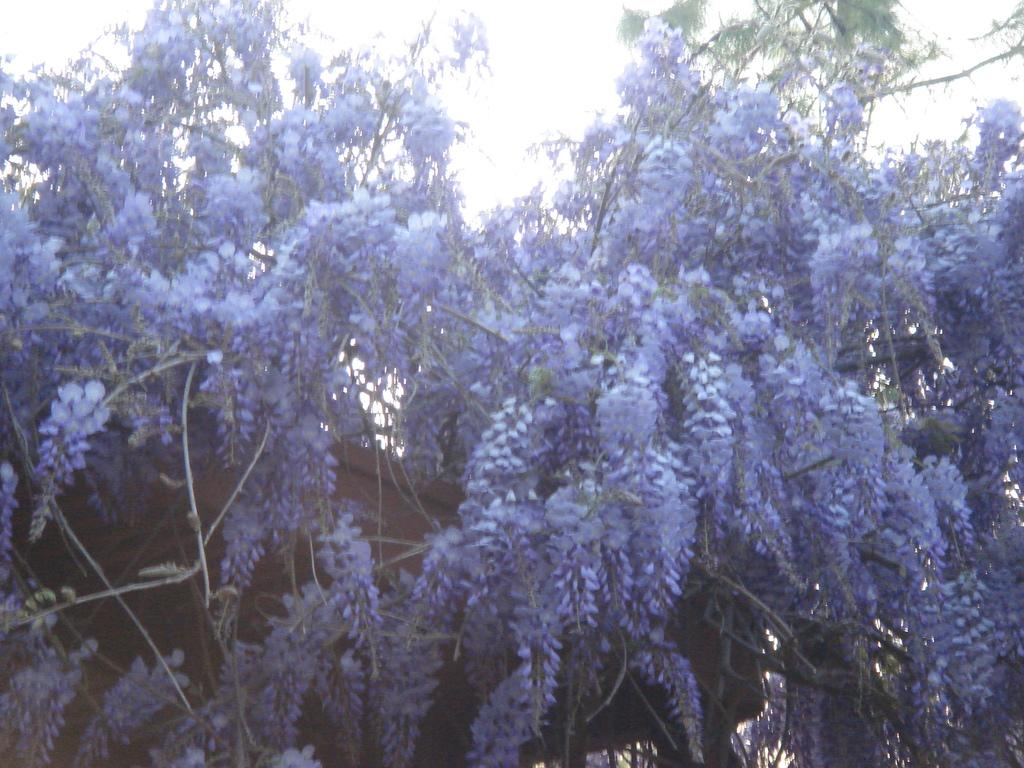What is the main subject of the image? The main subject of the image is a tree. What distinguishing feature can be observed on the tree? The tree has many purple flowers. What type of horn can be seen on the tree in the image? There is no horn present on the tree in the image. How many people are visible in the image? There are no people visible in the image; it only features a tree with purple flowers. 